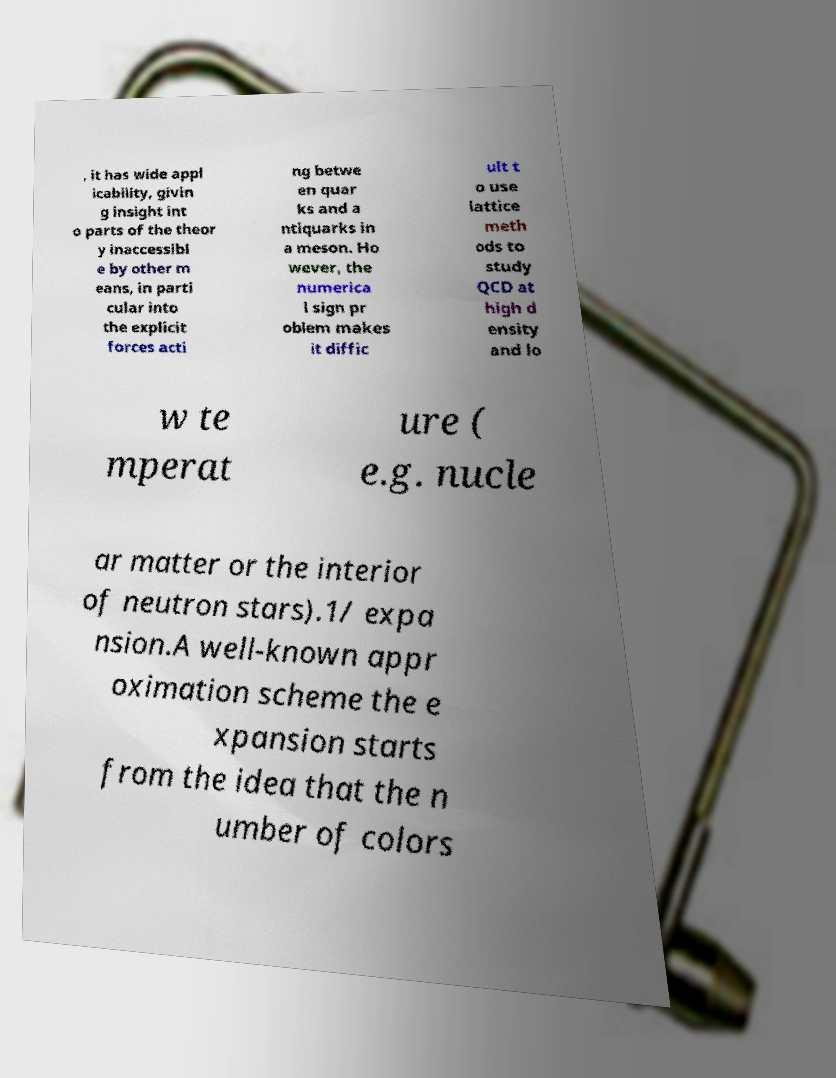There's text embedded in this image that I need extracted. Can you transcribe it verbatim? , it has wide appl icability, givin g insight int o parts of the theor y inaccessibl e by other m eans, in parti cular into the explicit forces acti ng betwe en quar ks and a ntiquarks in a meson. Ho wever, the numerica l sign pr oblem makes it diffic ult t o use lattice meth ods to study QCD at high d ensity and lo w te mperat ure ( e.g. nucle ar matter or the interior of neutron stars).1/ expa nsion.A well-known appr oximation scheme the e xpansion starts from the idea that the n umber of colors 